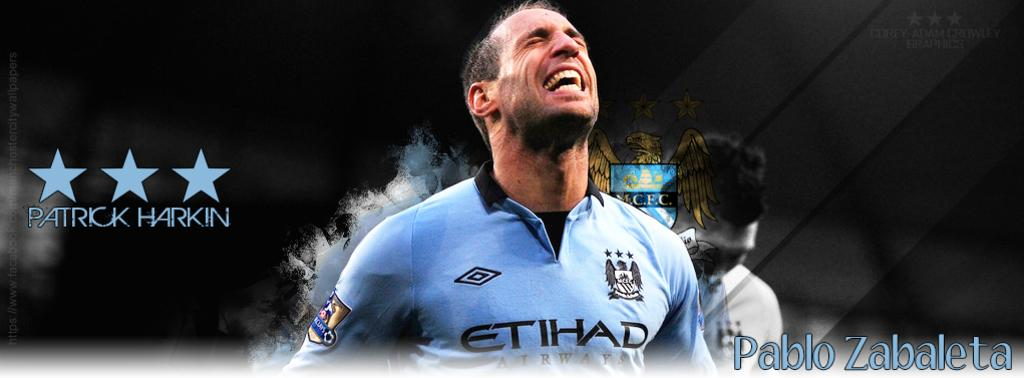<image>
Relay a brief, clear account of the picture shown. An Argentine soccer player named Pablo Zabaleta looks up with aspiration during a game. 